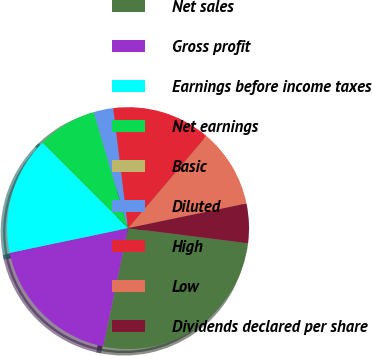<chart> <loc_0><loc_0><loc_500><loc_500><pie_chart><fcel>Net sales<fcel>Gross profit<fcel>Earnings before income taxes<fcel>Net earnings<fcel>Basic<fcel>Diluted<fcel>High<fcel>Low<fcel>Dividends declared per share<nl><fcel>26.31%<fcel>18.42%<fcel>15.79%<fcel>7.9%<fcel>0.0%<fcel>2.63%<fcel>13.16%<fcel>10.53%<fcel>5.26%<nl></chart> 